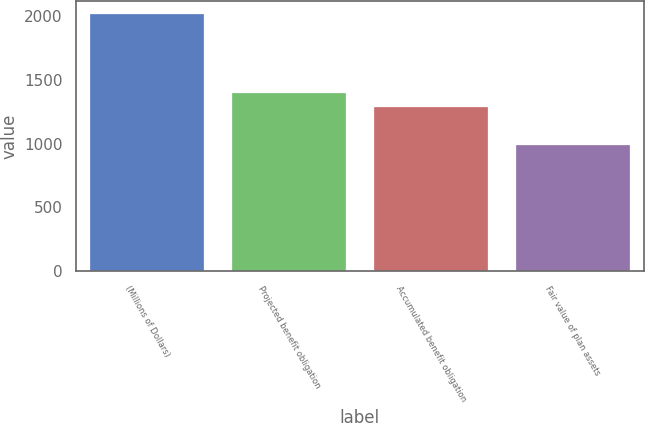<chart> <loc_0><loc_0><loc_500><loc_500><bar_chart><fcel>(Millions of Dollars)<fcel>Projected benefit obligation<fcel>Accumulated benefit obligation<fcel>Fair value of plan assets<nl><fcel>2016<fcel>1393.25<fcel>1290.7<fcel>990.5<nl></chart> 